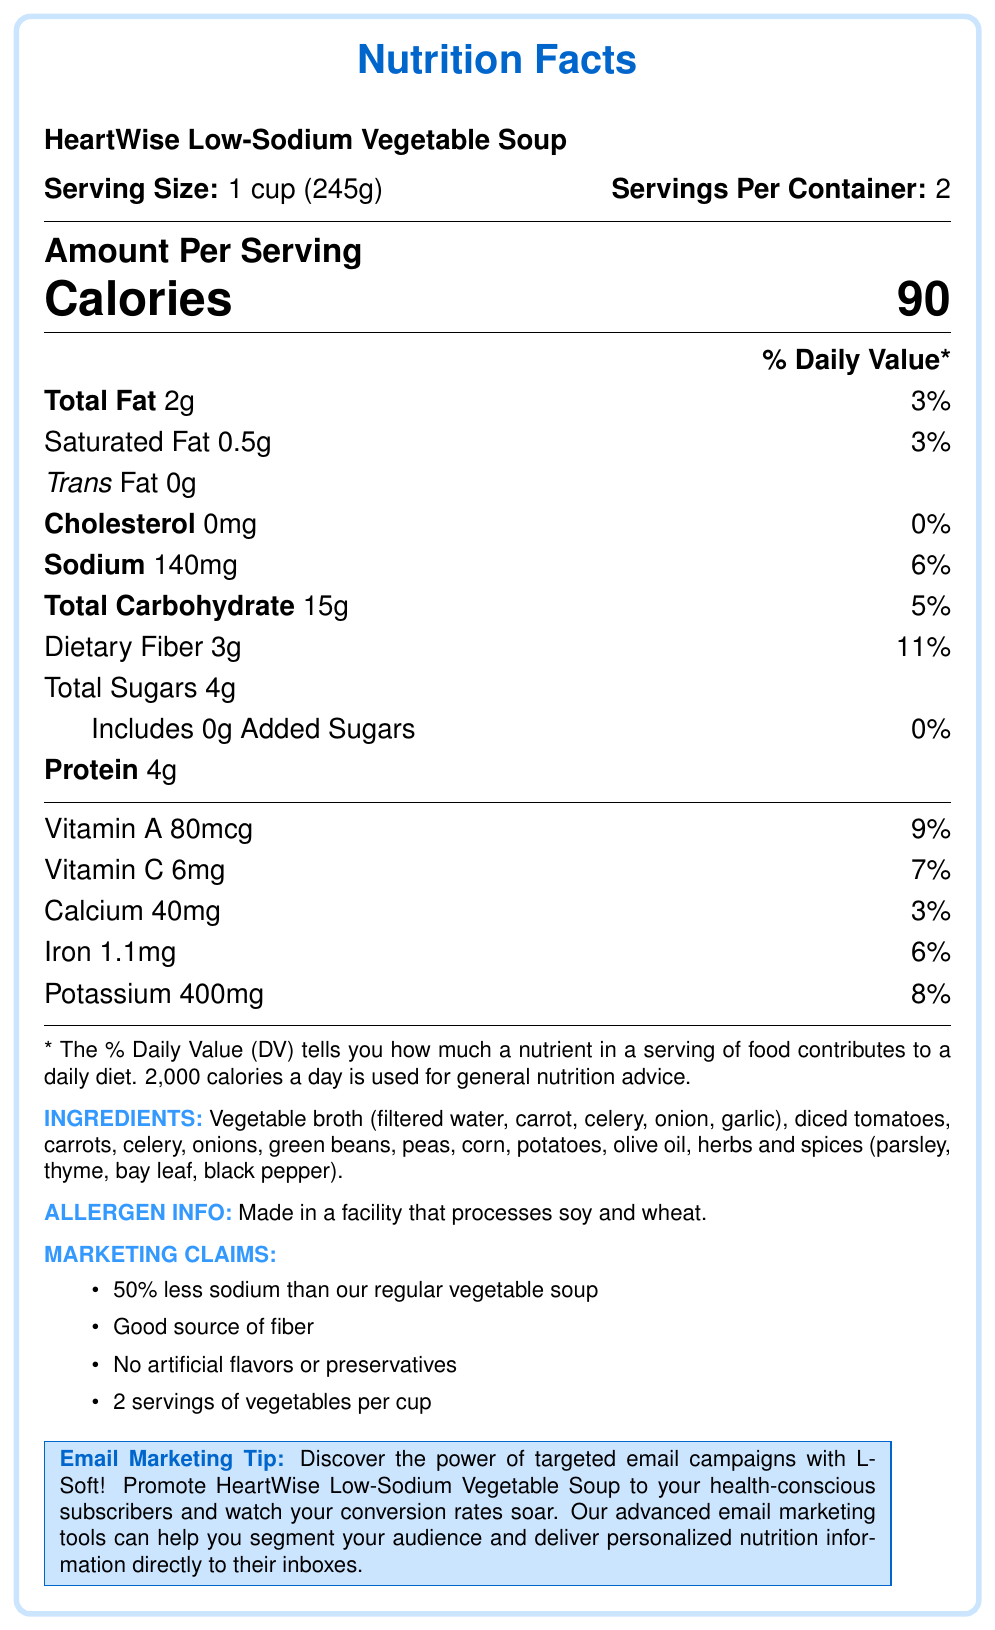What is the serving size of HeartWise Low-Sodium Vegetable Soup? The serving size is mentioned at the top of the document as "Serving Size: 1 cup (245g)".
Answer: 1 cup (245g) How many servings are in one container of HeartWise Low-Sodium Vegetable Soup? The servings per container are indicated in the document as "Servings Per Container: 2".
Answer: 2 What are the total calories per serving? The document states there are 90 calories per serving under "Amount Per Serving".
Answer: 90 What is the total fat content per serving? The total fat per serving is listed as 2g.
Answer: 2g How much sodium is in one serving of this soup? The amount of sodium per serving is given as "Sodium 140mg".
Answer: 140mg Which vitamin is present in the highest daily value percentage per serving? A. Vitamin A B. Vitamin C C. Iron D. Potassium Vitamin A has the highest daily value percentage at 9%, as listed in the vitamins section of the document.
Answer: A. Vitamin A Which of the following is not a marketing claim made by HeartWise Low-Sodium Vegetable Soup? A. 50% less sodium B. High in protein C. Good source of fiber D. No artificial flavors or preservatives The marketing claims include 50% less sodium, good source of fiber, and no artificial flavors or preservatives, but not high in protein.
Answer: B. High in protein Does the product contain any cholesterol? The document states under the cholesterol section "Cholesterol 0mg", indicating no cholesterol.
Answer: No Please summarize the key information provided in the Nutrition Facts label for HeartWise Low-Sodium Vegetable Soup. The document summarizes the nutritional content, including servings, calories, fats, sodium, vitamins, and minerals, and provides ingredient and allergen details along with marketing claims.
Answer: The document provides the nutritional facts for HeartWise Low-Sodium Vegetable Soup, showing it has 90 calories per serving with 2 servings per container. It contains 2g of total fat, 140mg of sodium, 15g of carbohydrates, 3g of dietary fiber, 4g of sugar, and 4g of protein per serving. It also lists vitamin A, vitamin C, calcium, iron, and potassium contents. Additionally, it mentions ingredients, allergen information, and several marketing claims. What is the daily value percentage of dietary fiber per serving? The dietary fiber daily value percentage is listed as 11% in the document.
Answer: 11% Does the product contain any added sugars? The document lists "Includes 0g Added Sugars", meaning there are no added sugars.
Answer: No How much protein does one serving of HeartWise Low-Sodium Vegetable Soup contain? The amount of protein per serving is directly listed in the nutrition facts as 4g.
Answer: 4g What is the ingredient with the most significant quantity in HeartWise Low-Sodium Vegetable Soup? The document lists ingredients but does not specify their quantities.
Answer: Not enough information In what type of facility is this product made? The allergen information states that the product is made in a facility that processes soy and wheat.
Answer: A facility that processes soy and wheat 